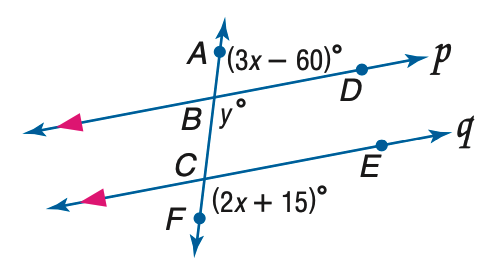Answer the mathemtical geometry problem and directly provide the correct option letter.
Question: Refer to the figure at the right. Find the value of y if p \parallel q.
Choices: A: 75 B: 85 C: 95 D: 105 D 